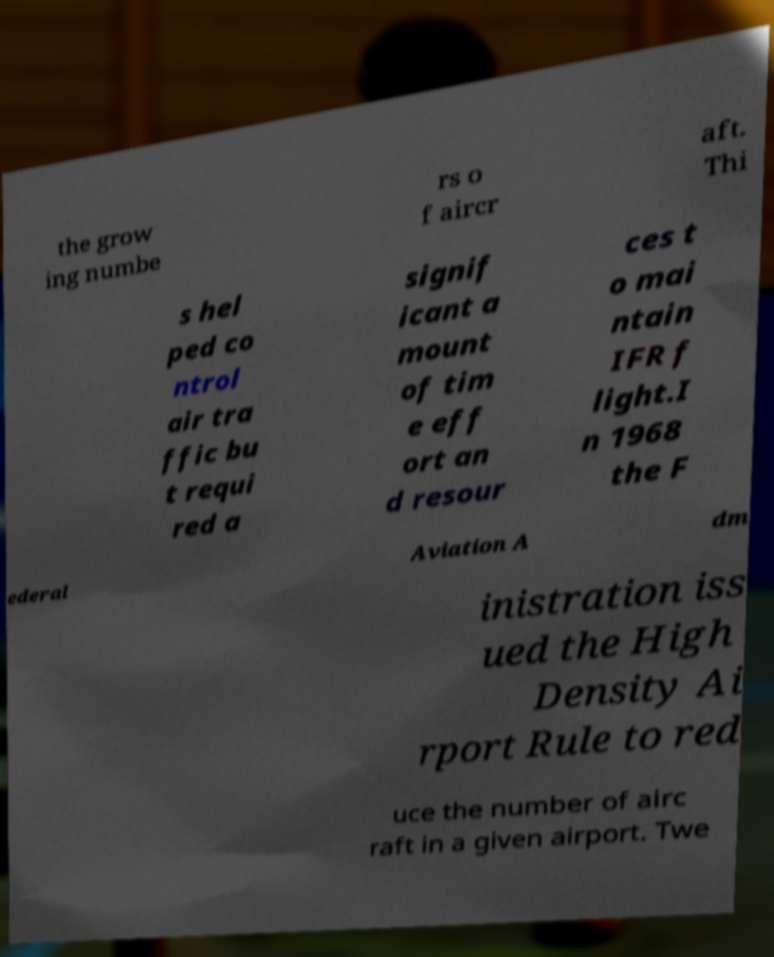For documentation purposes, I need the text within this image transcribed. Could you provide that? the grow ing numbe rs o f aircr aft. Thi s hel ped co ntrol air tra ffic bu t requi red a signif icant a mount of tim e eff ort an d resour ces t o mai ntain IFR f light.I n 1968 the F ederal Aviation A dm inistration iss ued the High Density Ai rport Rule to red uce the number of airc raft in a given airport. Twe 